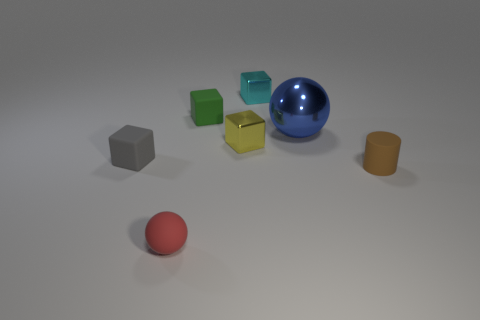The metallic sphere has what size?
Your answer should be very brief. Large. There is a blue shiny thing that is the same shape as the red thing; what is its size?
Your answer should be very brief. Large. Are there any other things that have the same size as the blue ball?
Offer a very short reply. No. Do the gray rubber object and the green rubber thing have the same size?
Provide a short and direct response. Yes. Are there more small gray cubes than big green cylinders?
Ensure brevity in your answer.  Yes. What number of things are tiny cyan metal blocks or metal objects?
Ensure brevity in your answer.  3. There is a tiny rubber thing that is on the left side of the tiny rubber ball; is its shape the same as the green object?
Offer a terse response. Yes. What color is the small cube that is behind the rubber block that is on the right side of the gray rubber block?
Your answer should be very brief. Cyan. Is the number of small rubber balls less than the number of small gray rubber spheres?
Keep it short and to the point. No. Is there a large purple ball that has the same material as the brown object?
Ensure brevity in your answer.  No. 